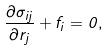<formula> <loc_0><loc_0><loc_500><loc_500>\frac { \partial \sigma _ { i j } } { \partial r _ { j } } + f _ { i } = 0 ,</formula> 